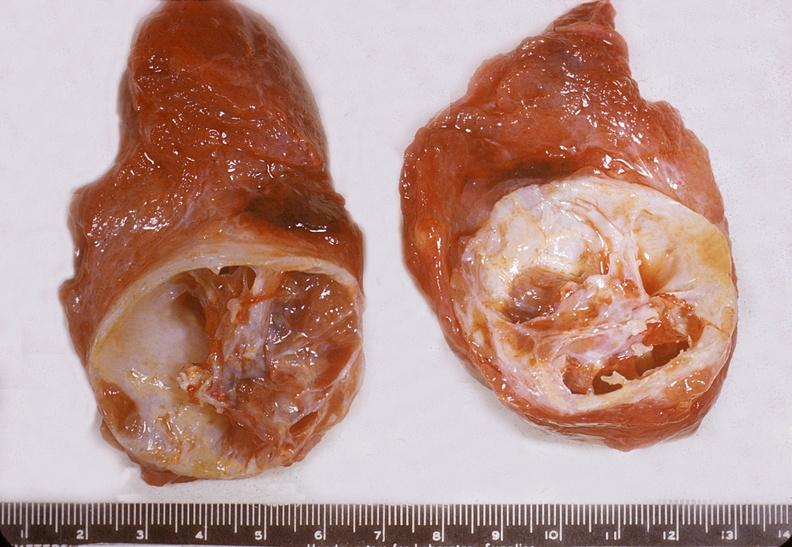s myocardium present?
Answer the question using a single word or phrase. No 